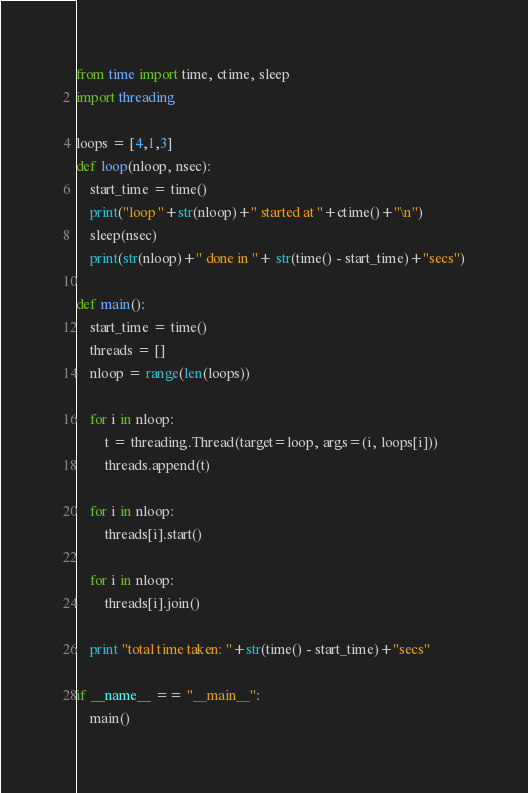Convert code to text. <code><loc_0><loc_0><loc_500><loc_500><_Python_>from time import time, ctime, sleep
import threading

loops = [4,1,3]
def loop(nloop, nsec):
    start_time = time()
    print("loop "+str(nloop)+" started at "+ctime()+"\n")
    sleep(nsec)
    print(str(nloop)+" done in "+ str(time() - start_time)+"secs")

def main():
    start_time = time()
    threads = []
    nloop = range(len(loops))

    for i in nloop:
        t = threading.Thread(target=loop, args=(i, loops[i]))
        threads.append(t)

    for i in nloop:
        threads[i].start()

    for i in nloop:
        threads[i].join()

    print "total time taken: "+str(time() - start_time)+"secs"

if __name__ == "__main__":
    main()
</code> 